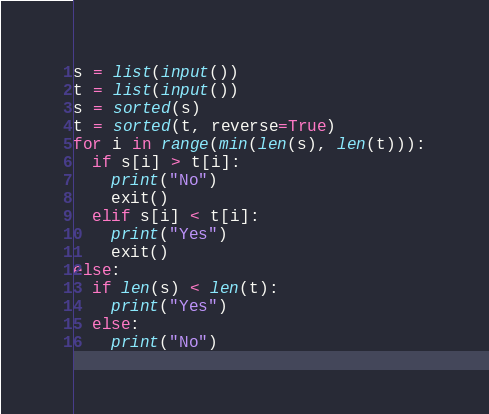Convert code to text. <code><loc_0><loc_0><loc_500><loc_500><_Python_>s = list(input())
t = list(input())
s = sorted(s)
t = sorted(t, reverse=True)
for i in range(min(len(s), len(t))):
  if s[i] > t[i]:
    print("No")
    exit()
  elif s[i] < t[i]:
    print("Yes")
    exit()
else:
  if len(s) < len(t):
    print("Yes")
  else:
    print("No")</code> 